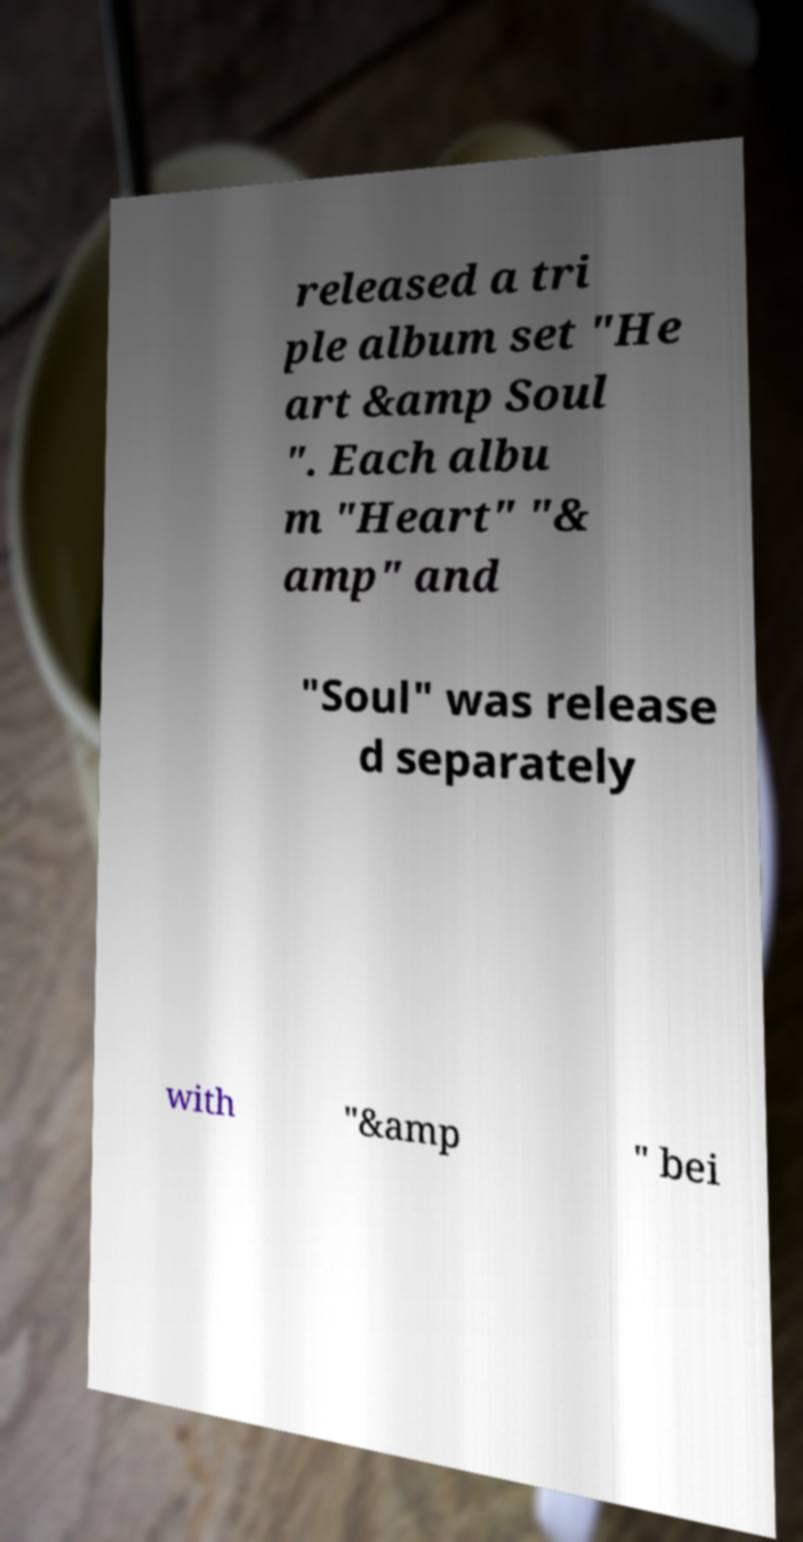Could you extract and type out the text from this image? released a tri ple album set "He art &amp Soul ". Each albu m "Heart" "& amp" and "Soul" was release d separately with "&amp " bei 